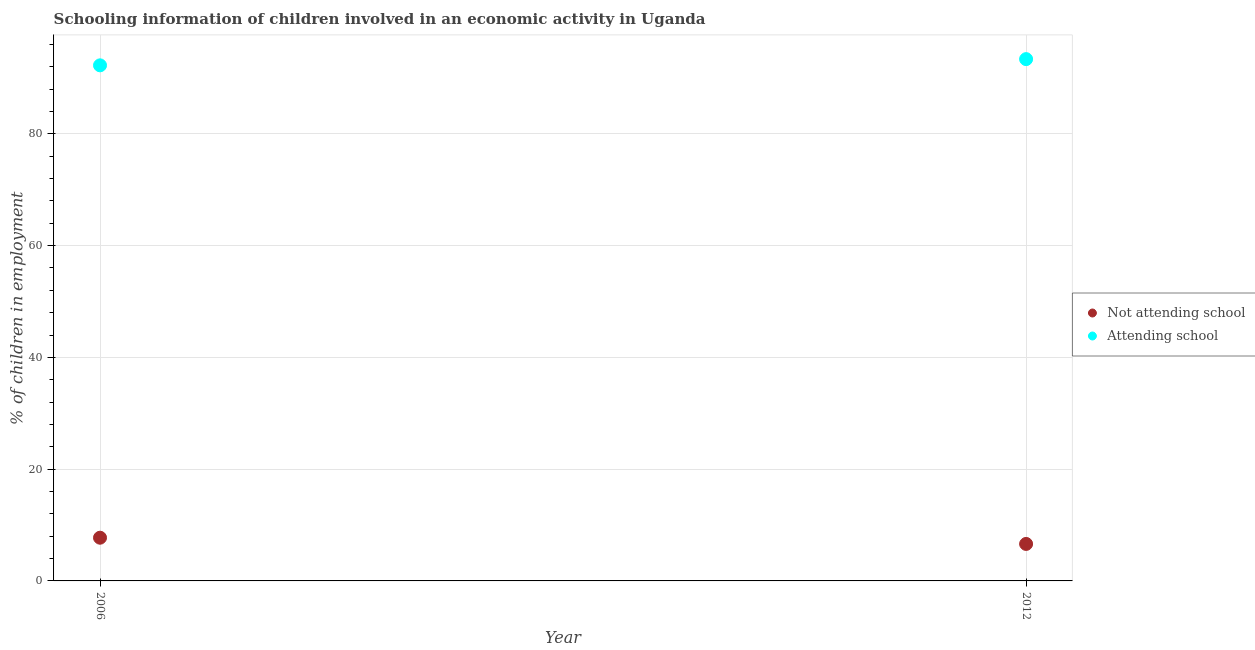How many different coloured dotlines are there?
Your answer should be compact. 2. Is the number of dotlines equal to the number of legend labels?
Give a very brief answer. Yes. What is the percentage of employed children who are not attending school in 2006?
Offer a terse response. 7.73. Across all years, what is the maximum percentage of employed children who are attending school?
Ensure brevity in your answer.  93.38. Across all years, what is the minimum percentage of employed children who are not attending school?
Provide a succinct answer. 6.62. In which year was the percentage of employed children who are attending school maximum?
Your answer should be very brief. 2012. In which year was the percentage of employed children who are not attending school minimum?
Your response must be concise. 2012. What is the total percentage of employed children who are attending school in the graph?
Provide a short and direct response. 185.65. What is the difference between the percentage of employed children who are attending school in 2006 and that in 2012?
Make the answer very short. -1.11. What is the difference between the percentage of employed children who are not attending school in 2006 and the percentage of employed children who are attending school in 2012?
Ensure brevity in your answer.  -85.65. What is the average percentage of employed children who are attending school per year?
Give a very brief answer. 92.82. In the year 2012, what is the difference between the percentage of employed children who are not attending school and percentage of employed children who are attending school?
Offer a terse response. -86.76. What is the ratio of the percentage of employed children who are not attending school in 2006 to that in 2012?
Your response must be concise. 1.17. Is the percentage of employed children who are attending school in 2006 less than that in 2012?
Give a very brief answer. Yes. Does the percentage of employed children who are attending school monotonically increase over the years?
Offer a very short reply. Yes. Is the percentage of employed children who are attending school strictly less than the percentage of employed children who are not attending school over the years?
Give a very brief answer. No. Are the values on the major ticks of Y-axis written in scientific E-notation?
Make the answer very short. No. Does the graph contain grids?
Your answer should be compact. Yes. How are the legend labels stacked?
Offer a terse response. Vertical. What is the title of the graph?
Offer a very short reply. Schooling information of children involved in an economic activity in Uganda. What is the label or title of the Y-axis?
Offer a terse response. % of children in employment. What is the % of children in employment of Not attending school in 2006?
Offer a terse response. 7.73. What is the % of children in employment of Attending school in 2006?
Give a very brief answer. 92.27. What is the % of children in employment in Not attending school in 2012?
Provide a short and direct response. 6.62. What is the % of children in employment of Attending school in 2012?
Provide a short and direct response. 93.38. Across all years, what is the maximum % of children in employment of Not attending school?
Give a very brief answer. 7.73. Across all years, what is the maximum % of children in employment in Attending school?
Make the answer very short. 93.38. Across all years, what is the minimum % of children in employment of Not attending school?
Provide a succinct answer. 6.62. Across all years, what is the minimum % of children in employment of Attending school?
Your response must be concise. 92.27. What is the total % of children in employment of Not attending school in the graph?
Your response must be concise. 14.35. What is the total % of children in employment in Attending school in the graph?
Your answer should be very brief. 185.65. What is the difference between the % of children in employment in Not attending school in 2006 and that in 2012?
Offer a very short reply. 1.11. What is the difference between the % of children in employment in Attending school in 2006 and that in 2012?
Your answer should be compact. -1.11. What is the difference between the % of children in employment in Not attending school in 2006 and the % of children in employment in Attending school in 2012?
Keep it short and to the point. -85.65. What is the average % of children in employment of Not attending school per year?
Make the answer very short. 7.18. What is the average % of children in employment of Attending school per year?
Give a very brief answer. 92.82. In the year 2006, what is the difference between the % of children in employment in Not attending school and % of children in employment in Attending school?
Offer a very short reply. -84.54. In the year 2012, what is the difference between the % of children in employment in Not attending school and % of children in employment in Attending school?
Your answer should be compact. -86.76. What is the ratio of the % of children in employment of Not attending school in 2006 to that in 2012?
Offer a terse response. 1.17. What is the difference between the highest and the second highest % of children in employment in Not attending school?
Your response must be concise. 1.11. What is the difference between the highest and the second highest % of children in employment of Attending school?
Your answer should be compact. 1.11. What is the difference between the highest and the lowest % of children in employment in Not attending school?
Ensure brevity in your answer.  1.11. What is the difference between the highest and the lowest % of children in employment of Attending school?
Offer a very short reply. 1.11. 